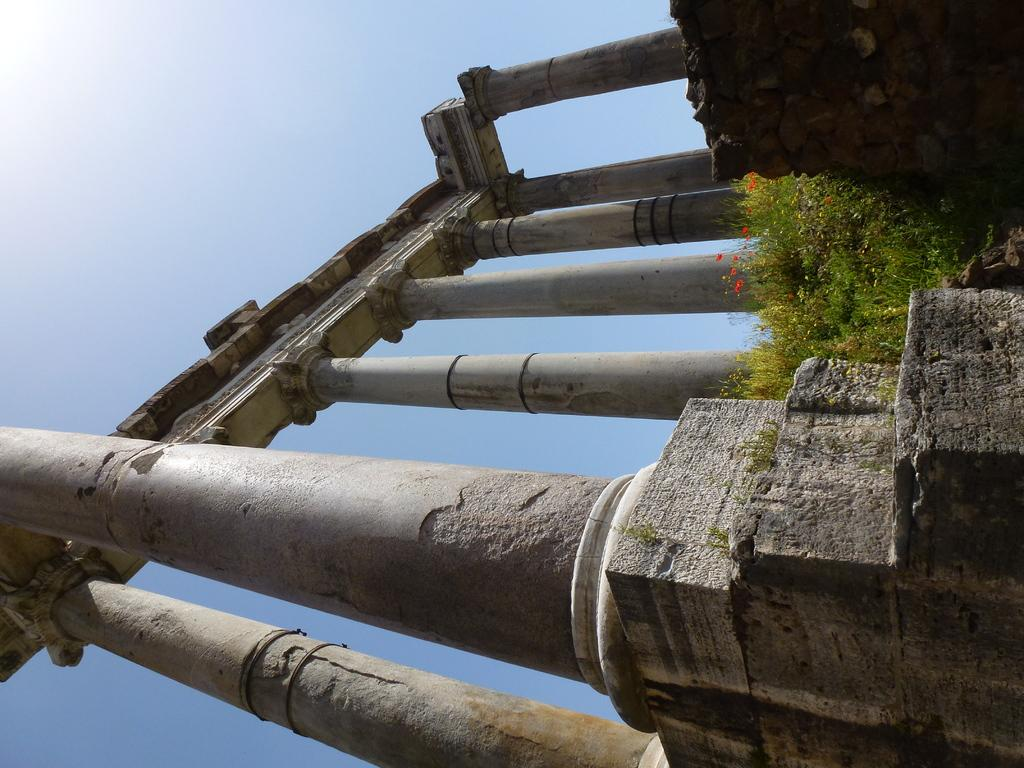What objects are present in the image? There are poles in the image. What can be seen on the plants in the image? There are flowers on the plants in the image. What is the condition of the sky in the image? The sky is clear in the image. Can you tell me how many people are shown respecting the poles in the image? There are no people present in the image, so it is not possible to determine how many people might be showing respect for the poles. 